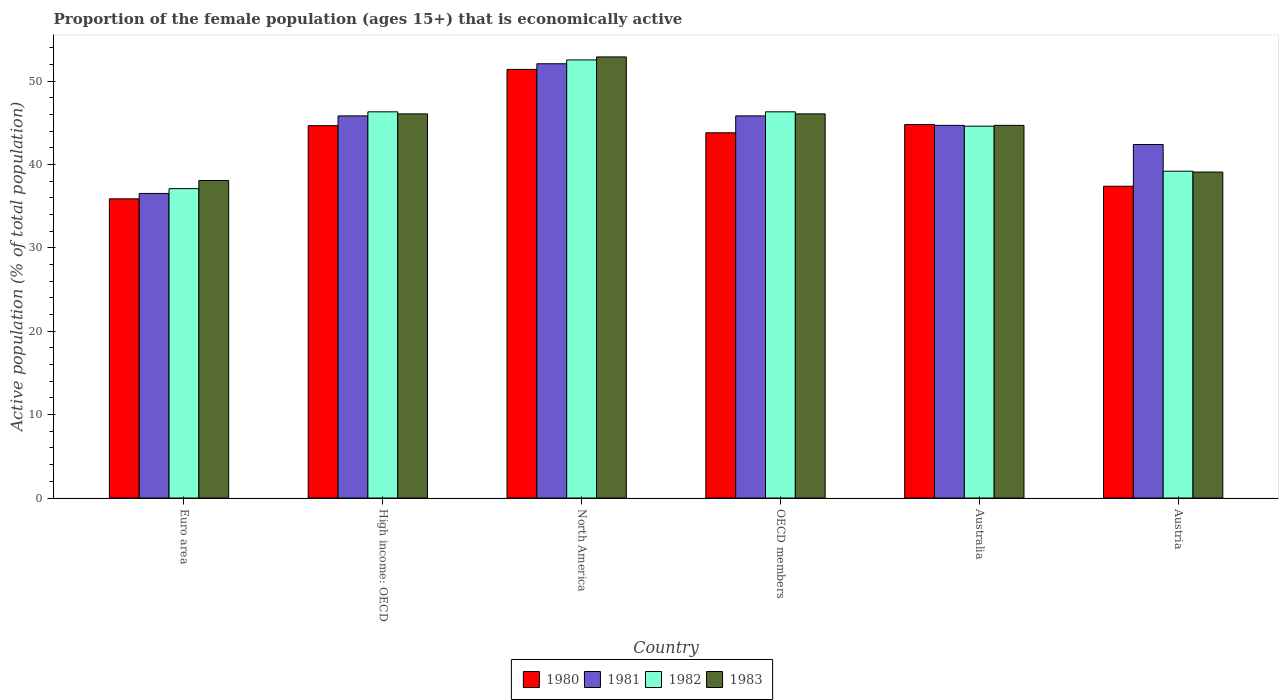How many different coloured bars are there?
Make the answer very short. 4. How many bars are there on the 6th tick from the left?
Provide a succinct answer. 4. What is the label of the 1st group of bars from the left?
Provide a short and direct response. Euro area. In how many cases, is the number of bars for a given country not equal to the number of legend labels?
Provide a succinct answer. 0. What is the proportion of the female population that is economically active in 1981 in High income: OECD?
Provide a succinct answer. 45.84. Across all countries, what is the maximum proportion of the female population that is economically active in 1983?
Your answer should be compact. 52.91. Across all countries, what is the minimum proportion of the female population that is economically active in 1982?
Ensure brevity in your answer.  37.11. In which country was the proportion of the female population that is economically active in 1982 maximum?
Your answer should be compact. North America. In which country was the proportion of the female population that is economically active in 1982 minimum?
Provide a succinct answer. Euro area. What is the total proportion of the female population that is economically active in 1982 in the graph?
Make the answer very short. 266.11. What is the difference between the proportion of the female population that is economically active in 1982 in Australia and that in High income: OECD?
Ensure brevity in your answer.  -1.72. What is the difference between the proportion of the female population that is economically active in 1983 in Euro area and the proportion of the female population that is economically active in 1981 in Austria?
Provide a short and direct response. -4.31. What is the average proportion of the female population that is economically active in 1981 per country?
Make the answer very short. 44.57. What is the difference between the proportion of the female population that is economically active of/in 1981 and proportion of the female population that is economically active of/in 1983 in OECD members?
Offer a very short reply. -0.24. What is the ratio of the proportion of the female population that is economically active in 1982 in Australia to that in Austria?
Give a very brief answer. 1.14. Is the difference between the proportion of the female population that is economically active in 1981 in Australia and Euro area greater than the difference between the proportion of the female population that is economically active in 1983 in Australia and Euro area?
Your answer should be compact. Yes. What is the difference between the highest and the second highest proportion of the female population that is economically active in 1983?
Offer a very short reply. 6.83. What is the difference between the highest and the lowest proportion of the female population that is economically active in 1981?
Your answer should be compact. 15.56. What does the 3rd bar from the right in OECD members represents?
Offer a very short reply. 1981. Are all the bars in the graph horizontal?
Your response must be concise. No. What is the difference between two consecutive major ticks on the Y-axis?
Your response must be concise. 10. Are the values on the major ticks of Y-axis written in scientific E-notation?
Provide a succinct answer. No. Does the graph contain any zero values?
Offer a very short reply. No. Does the graph contain grids?
Offer a terse response. No. How are the legend labels stacked?
Make the answer very short. Horizontal. What is the title of the graph?
Make the answer very short. Proportion of the female population (ages 15+) that is economically active. What is the label or title of the X-axis?
Offer a terse response. Country. What is the label or title of the Y-axis?
Provide a short and direct response. Active population (% of total population). What is the Active population (% of total population) in 1980 in Euro area?
Ensure brevity in your answer.  35.89. What is the Active population (% of total population) of 1981 in Euro area?
Provide a short and direct response. 36.53. What is the Active population (% of total population) in 1982 in Euro area?
Provide a short and direct response. 37.11. What is the Active population (% of total population) of 1983 in Euro area?
Give a very brief answer. 38.09. What is the Active population (% of total population) of 1980 in High income: OECD?
Make the answer very short. 44.66. What is the Active population (% of total population) in 1981 in High income: OECD?
Your answer should be very brief. 45.84. What is the Active population (% of total population) in 1982 in High income: OECD?
Keep it short and to the point. 46.32. What is the Active population (% of total population) of 1983 in High income: OECD?
Your answer should be very brief. 46.08. What is the Active population (% of total population) of 1980 in North America?
Ensure brevity in your answer.  51.41. What is the Active population (% of total population) in 1981 in North America?
Give a very brief answer. 52.09. What is the Active population (% of total population) in 1982 in North America?
Offer a very short reply. 52.55. What is the Active population (% of total population) in 1983 in North America?
Provide a short and direct response. 52.91. What is the Active population (% of total population) of 1980 in OECD members?
Your response must be concise. 43.81. What is the Active population (% of total population) of 1981 in OECD members?
Your answer should be very brief. 45.84. What is the Active population (% of total population) in 1982 in OECD members?
Ensure brevity in your answer.  46.32. What is the Active population (% of total population) of 1983 in OECD members?
Your answer should be compact. 46.08. What is the Active population (% of total population) of 1980 in Australia?
Provide a short and direct response. 44.8. What is the Active population (% of total population) of 1981 in Australia?
Ensure brevity in your answer.  44.7. What is the Active population (% of total population) of 1982 in Australia?
Offer a very short reply. 44.6. What is the Active population (% of total population) in 1983 in Australia?
Ensure brevity in your answer.  44.7. What is the Active population (% of total population) in 1980 in Austria?
Your answer should be very brief. 37.4. What is the Active population (% of total population) of 1981 in Austria?
Offer a very short reply. 42.4. What is the Active population (% of total population) of 1982 in Austria?
Keep it short and to the point. 39.2. What is the Active population (% of total population) in 1983 in Austria?
Ensure brevity in your answer.  39.1. Across all countries, what is the maximum Active population (% of total population) in 1980?
Your answer should be compact. 51.41. Across all countries, what is the maximum Active population (% of total population) of 1981?
Your answer should be very brief. 52.09. Across all countries, what is the maximum Active population (% of total population) in 1982?
Your response must be concise. 52.55. Across all countries, what is the maximum Active population (% of total population) of 1983?
Provide a succinct answer. 52.91. Across all countries, what is the minimum Active population (% of total population) of 1980?
Provide a succinct answer. 35.89. Across all countries, what is the minimum Active population (% of total population) in 1981?
Give a very brief answer. 36.53. Across all countries, what is the minimum Active population (% of total population) in 1982?
Keep it short and to the point. 37.11. Across all countries, what is the minimum Active population (% of total population) in 1983?
Keep it short and to the point. 38.09. What is the total Active population (% of total population) in 1980 in the graph?
Provide a succinct answer. 257.97. What is the total Active population (% of total population) of 1981 in the graph?
Your answer should be compact. 267.4. What is the total Active population (% of total population) of 1982 in the graph?
Provide a succinct answer. 266.11. What is the total Active population (% of total population) in 1983 in the graph?
Your answer should be compact. 266.95. What is the difference between the Active population (% of total population) of 1980 in Euro area and that in High income: OECD?
Keep it short and to the point. -8.78. What is the difference between the Active population (% of total population) of 1981 in Euro area and that in High income: OECD?
Your response must be concise. -9.3. What is the difference between the Active population (% of total population) in 1982 in Euro area and that in High income: OECD?
Your answer should be very brief. -9.22. What is the difference between the Active population (% of total population) of 1983 in Euro area and that in High income: OECD?
Your answer should be very brief. -7.99. What is the difference between the Active population (% of total population) in 1980 in Euro area and that in North America?
Ensure brevity in your answer.  -15.53. What is the difference between the Active population (% of total population) of 1981 in Euro area and that in North America?
Your answer should be compact. -15.56. What is the difference between the Active population (% of total population) in 1982 in Euro area and that in North America?
Your response must be concise. -15.44. What is the difference between the Active population (% of total population) of 1983 in Euro area and that in North America?
Provide a succinct answer. -14.82. What is the difference between the Active population (% of total population) in 1980 in Euro area and that in OECD members?
Provide a succinct answer. -7.92. What is the difference between the Active population (% of total population) in 1981 in Euro area and that in OECD members?
Offer a terse response. -9.3. What is the difference between the Active population (% of total population) of 1982 in Euro area and that in OECD members?
Give a very brief answer. -9.22. What is the difference between the Active population (% of total population) in 1983 in Euro area and that in OECD members?
Give a very brief answer. -7.99. What is the difference between the Active population (% of total population) of 1980 in Euro area and that in Australia?
Offer a terse response. -8.91. What is the difference between the Active population (% of total population) of 1981 in Euro area and that in Australia?
Offer a very short reply. -8.17. What is the difference between the Active population (% of total population) of 1982 in Euro area and that in Australia?
Ensure brevity in your answer.  -7.49. What is the difference between the Active population (% of total population) of 1983 in Euro area and that in Australia?
Give a very brief answer. -6.61. What is the difference between the Active population (% of total population) in 1980 in Euro area and that in Austria?
Provide a succinct answer. -1.51. What is the difference between the Active population (% of total population) of 1981 in Euro area and that in Austria?
Your response must be concise. -5.87. What is the difference between the Active population (% of total population) in 1982 in Euro area and that in Austria?
Provide a succinct answer. -2.09. What is the difference between the Active population (% of total population) of 1983 in Euro area and that in Austria?
Ensure brevity in your answer.  -1.01. What is the difference between the Active population (% of total population) in 1980 in High income: OECD and that in North America?
Ensure brevity in your answer.  -6.75. What is the difference between the Active population (% of total population) in 1981 in High income: OECD and that in North America?
Your response must be concise. -6.25. What is the difference between the Active population (% of total population) of 1982 in High income: OECD and that in North America?
Offer a very short reply. -6.23. What is the difference between the Active population (% of total population) of 1983 in High income: OECD and that in North America?
Your answer should be very brief. -6.83. What is the difference between the Active population (% of total population) in 1980 in High income: OECD and that in OECD members?
Offer a terse response. 0.85. What is the difference between the Active population (% of total population) of 1981 in High income: OECD and that in OECD members?
Offer a terse response. 0. What is the difference between the Active population (% of total population) in 1980 in High income: OECD and that in Australia?
Provide a short and direct response. -0.14. What is the difference between the Active population (% of total population) of 1981 in High income: OECD and that in Australia?
Ensure brevity in your answer.  1.14. What is the difference between the Active population (% of total population) of 1982 in High income: OECD and that in Australia?
Offer a very short reply. 1.72. What is the difference between the Active population (% of total population) in 1983 in High income: OECD and that in Australia?
Your response must be concise. 1.38. What is the difference between the Active population (% of total population) in 1980 in High income: OECD and that in Austria?
Keep it short and to the point. 7.26. What is the difference between the Active population (% of total population) of 1981 in High income: OECD and that in Austria?
Your answer should be compact. 3.44. What is the difference between the Active population (% of total population) of 1982 in High income: OECD and that in Austria?
Your answer should be compact. 7.12. What is the difference between the Active population (% of total population) of 1983 in High income: OECD and that in Austria?
Ensure brevity in your answer.  6.98. What is the difference between the Active population (% of total population) of 1980 in North America and that in OECD members?
Provide a succinct answer. 7.61. What is the difference between the Active population (% of total population) of 1981 in North America and that in OECD members?
Ensure brevity in your answer.  6.25. What is the difference between the Active population (% of total population) of 1982 in North America and that in OECD members?
Your answer should be very brief. 6.23. What is the difference between the Active population (% of total population) in 1983 in North America and that in OECD members?
Your response must be concise. 6.83. What is the difference between the Active population (% of total population) of 1980 in North America and that in Australia?
Your answer should be very brief. 6.61. What is the difference between the Active population (% of total population) in 1981 in North America and that in Australia?
Give a very brief answer. 7.39. What is the difference between the Active population (% of total population) of 1982 in North America and that in Australia?
Give a very brief answer. 7.95. What is the difference between the Active population (% of total population) of 1983 in North America and that in Australia?
Your answer should be compact. 8.21. What is the difference between the Active population (% of total population) in 1980 in North America and that in Austria?
Make the answer very short. 14.01. What is the difference between the Active population (% of total population) in 1981 in North America and that in Austria?
Your answer should be compact. 9.69. What is the difference between the Active population (% of total population) of 1982 in North America and that in Austria?
Your response must be concise. 13.35. What is the difference between the Active population (% of total population) in 1983 in North America and that in Austria?
Your answer should be very brief. 13.81. What is the difference between the Active population (% of total population) of 1980 in OECD members and that in Australia?
Offer a very short reply. -0.99. What is the difference between the Active population (% of total population) in 1981 in OECD members and that in Australia?
Your answer should be compact. 1.14. What is the difference between the Active population (% of total population) of 1982 in OECD members and that in Australia?
Your answer should be compact. 1.72. What is the difference between the Active population (% of total population) of 1983 in OECD members and that in Australia?
Your answer should be very brief. 1.38. What is the difference between the Active population (% of total population) of 1980 in OECD members and that in Austria?
Your answer should be very brief. 6.41. What is the difference between the Active population (% of total population) of 1981 in OECD members and that in Austria?
Offer a very short reply. 3.44. What is the difference between the Active population (% of total population) of 1982 in OECD members and that in Austria?
Provide a succinct answer. 7.12. What is the difference between the Active population (% of total population) of 1983 in OECD members and that in Austria?
Provide a short and direct response. 6.98. What is the difference between the Active population (% of total population) of 1980 in Australia and that in Austria?
Keep it short and to the point. 7.4. What is the difference between the Active population (% of total population) of 1981 in Australia and that in Austria?
Make the answer very short. 2.3. What is the difference between the Active population (% of total population) of 1980 in Euro area and the Active population (% of total population) of 1981 in High income: OECD?
Offer a terse response. -9.95. What is the difference between the Active population (% of total population) of 1980 in Euro area and the Active population (% of total population) of 1982 in High income: OECD?
Provide a succinct answer. -10.44. What is the difference between the Active population (% of total population) of 1980 in Euro area and the Active population (% of total population) of 1983 in High income: OECD?
Your answer should be very brief. -10.19. What is the difference between the Active population (% of total population) of 1981 in Euro area and the Active population (% of total population) of 1982 in High income: OECD?
Your response must be concise. -9.79. What is the difference between the Active population (% of total population) in 1981 in Euro area and the Active population (% of total population) in 1983 in High income: OECD?
Ensure brevity in your answer.  -9.54. What is the difference between the Active population (% of total population) in 1982 in Euro area and the Active population (% of total population) in 1983 in High income: OECD?
Offer a terse response. -8.97. What is the difference between the Active population (% of total population) in 1980 in Euro area and the Active population (% of total population) in 1981 in North America?
Your answer should be compact. -16.2. What is the difference between the Active population (% of total population) of 1980 in Euro area and the Active population (% of total population) of 1982 in North America?
Give a very brief answer. -16.67. What is the difference between the Active population (% of total population) in 1980 in Euro area and the Active population (% of total population) in 1983 in North America?
Offer a very short reply. -17.02. What is the difference between the Active population (% of total population) in 1981 in Euro area and the Active population (% of total population) in 1982 in North America?
Provide a succinct answer. -16.02. What is the difference between the Active population (% of total population) in 1981 in Euro area and the Active population (% of total population) in 1983 in North America?
Ensure brevity in your answer.  -16.38. What is the difference between the Active population (% of total population) of 1982 in Euro area and the Active population (% of total population) of 1983 in North America?
Provide a succinct answer. -15.8. What is the difference between the Active population (% of total population) of 1980 in Euro area and the Active population (% of total population) of 1981 in OECD members?
Provide a succinct answer. -9.95. What is the difference between the Active population (% of total population) in 1980 in Euro area and the Active population (% of total population) in 1982 in OECD members?
Your answer should be very brief. -10.44. What is the difference between the Active population (% of total population) in 1980 in Euro area and the Active population (% of total population) in 1983 in OECD members?
Make the answer very short. -10.19. What is the difference between the Active population (% of total population) in 1981 in Euro area and the Active population (% of total population) in 1982 in OECD members?
Give a very brief answer. -9.79. What is the difference between the Active population (% of total population) of 1981 in Euro area and the Active population (% of total population) of 1983 in OECD members?
Offer a terse response. -9.54. What is the difference between the Active population (% of total population) of 1982 in Euro area and the Active population (% of total population) of 1983 in OECD members?
Offer a terse response. -8.97. What is the difference between the Active population (% of total population) in 1980 in Euro area and the Active population (% of total population) in 1981 in Australia?
Offer a terse response. -8.81. What is the difference between the Active population (% of total population) of 1980 in Euro area and the Active population (% of total population) of 1982 in Australia?
Your response must be concise. -8.71. What is the difference between the Active population (% of total population) of 1980 in Euro area and the Active population (% of total population) of 1983 in Australia?
Offer a terse response. -8.81. What is the difference between the Active population (% of total population) in 1981 in Euro area and the Active population (% of total population) in 1982 in Australia?
Offer a very short reply. -8.07. What is the difference between the Active population (% of total population) of 1981 in Euro area and the Active population (% of total population) of 1983 in Australia?
Provide a succinct answer. -8.17. What is the difference between the Active population (% of total population) in 1982 in Euro area and the Active population (% of total population) in 1983 in Australia?
Offer a very short reply. -7.59. What is the difference between the Active population (% of total population) of 1980 in Euro area and the Active population (% of total population) of 1981 in Austria?
Keep it short and to the point. -6.51. What is the difference between the Active population (% of total population) in 1980 in Euro area and the Active population (% of total population) in 1982 in Austria?
Provide a short and direct response. -3.31. What is the difference between the Active population (% of total population) in 1980 in Euro area and the Active population (% of total population) in 1983 in Austria?
Give a very brief answer. -3.21. What is the difference between the Active population (% of total population) of 1981 in Euro area and the Active population (% of total population) of 1982 in Austria?
Make the answer very short. -2.67. What is the difference between the Active population (% of total population) in 1981 in Euro area and the Active population (% of total population) in 1983 in Austria?
Give a very brief answer. -2.57. What is the difference between the Active population (% of total population) in 1982 in Euro area and the Active population (% of total population) in 1983 in Austria?
Provide a short and direct response. -1.99. What is the difference between the Active population (% of total population) of 1980 in High income: OECD and the Active population (% of total population) of 1981 in North America?
Provide a short and direct response. -7.43. What is the difference between the Active population (% of total population) in 1980 in High income: OECD and the Active population (% of total population) in 1982 in North America?
Give a very brief answer. -7.89. What is the difference between the Active population (% of total population) in 1980 in High income: OECD and the Active population (% of total population) in 1983 in North America?
Offer a terse response. -8.25. What is the difference between the Active population (% of total population) of 1981 in High income: OECD and the Active population (% of total population) of 1982 in North America?
Keep it short and to the point. -6.72. What is the difference between the Active population (% of total population) of 1981 in High income: OECD and the Active population (% of total population) of 1983 in North America?
Provide a succinct answer. -7.07. What is the difference between the Active population (% of total population) of 1982 in High income: OECD and the Active population (% of total population) of 1983 in North America?
Make the answer very short. -6.58. What is the difference between the Active population (% of total population) in 1980 in High income: OECD and the Active population (% of total population) in 1981 in OECD members?
Make the answer very short. -1.17. What is the difference between the Active population (% of total population) in 1980 in High income: OECD and the Active population (% of total population) in 1982 in OECD members?
Offer a terse response. -1.66. What is the difference between the Active population (% of total population) in 1980 in High income: OECD and the Active population (% of total population) in 1983 in OECD members?
Offer a very short reply. -1.42. What is the difference between the Active population (% of total population) in 1981 in High income: OECD and the Active population (% of total population) in 1982 in OECD members?
Make the answer very short. -0.49. What is the difference between the Active population (% of total population) in 1981 in High income: OECD and the Active population (% of total population) in 1983 in OECD members?
Ensure brevity in your answer.  -0.24. What is the difference between the Active population (% of total population) in 1982 in High income: OECD and the Active population (% of total population) in 1983 in OECD members?
Offer a terse response. 0.25. What is the difference between the Active population (% of total population) of 1980 in High income: OECD and the Active population (% of total population) of 1981 in Australia?
Your answer should be compact. -0.04. What is the difference between the Active population (% of total population) of 1980 in High income: OECD and the Active population (% of total population) of 1982 in Australia?
Ensure brevity in your answer.  0.06. What is the difference between the Active population (% of total population) of 1980 in High income: OECD and the Active population (% of total population) of 1983 in Australia?
Make the answer very short. -0.04. What is the difference between the Active population (% of total population) in 1981 in High income: OECD and the Active population (% of total population) in 1982 in Australia?
Offer a very short reply. 1.24. What is the difference between the Active population (% of total population) of 1981 in High income: OECD and the Active population (% of total population) of 1983 in Australia?
Offer a very short reply. 1.14. What is the difference between the Active population (% of total population) of 1982 in High income: OECD and the Active population (% of total population) of 1983 in Australia?
Offer a terse response. 1.62. What is the difference between the Active population (% of total population) in 1980 in High income: OECD and the Active population (% of total population) in 1981 in Austria?
Provide a short and direct response. 2.26. What is the difference between the Active population (% of total population) in 1980 in High income: OECD and the Active population (% of total population) in 1982 in Austria?
Keep it short and to the point. 5.46. What is the difference between the Active population (% of total population) of 1980 in High income: OECD and the Active population (% of total population) of 1983 in Austria?
Your response must be concise. 5.56. What is the difference between the Active population (% of total population) in 1981 in High income: OECD and the Active population (% of total population) in 1982 in Austria?
Your response must be concise. 6.64. What is the difference between the Active population (% of total population) in 1981 in High income: OECD and the Active population (% of total population) in 1983 in Austria?
Provide a succinct answer. 6.74. What is the difference between the Active population (% of total population) in 1982 in High income: OECD and the Active population (% of total population) in 1983 in Austria?
Your answer should be compact. 7.22. What is the difference between the Active population (% of total population) in 1980 in North America and the Active population (% of total population) in 1981 in OECD members?
Give a very brief answer. 5.58. What is the difference between the Active population (% of total population) of 1980 in North America and the Active population (% of total population) of 1982 in OECD members?
Keep it short and to the point. 5.09. What is the difference between the Active population (% of total population) of 1980 in North America and the Active population (% of total population) of 1983 in OECD members?
Keep it short and to the point. 5.34. What is the difference between the Active population (% of total population) in 1981 in North America and the Active population (% of total population) in 1982 in OECD members?
Your answer should be very brief. 5.77. What is the difference between the Active population (% of total population) of 1981 in North America and the Active population (% of total population) of 1983 in OECD members?
Offer a very short reply. 6.01. What is the difference between the Active population (% of total population) of 1982 in North America and the Active population (% of total population) of 1983 in OECD members?
Provide a short and direct response. 6.47. What is the difference between the Active population (% of total population) in 1980 in North America and the Active population (% of total population) in 1981 in Australia?
Your response must be concise. 6.71. What is the difference between the Active population (% of total population) of 1980 in North America and the Active population (% of total population) of 1982 in Australia?
Keep it short and to the point. 6.81. What is the difference between the Active population (% of total population) of 1980 in North America and the Active population (% of total population) of 1983 in Australia?
Provide a succinct answer. 6.71. What is the difference between the Active population (% of total population) of 1981 in North America and the Active population (% of total population) of 1982 in Australia?
Give a very brief answer. 7.49. What is the difference between the Active population (% of total population) in 1981 in North America and the Active population (% of total population) in 1983 in Australia?
Your response must be concise. 7.39. What is the difference between the Active population (% of total population) of 1982 in North America and the Active population (% of total population) of 1983 in Australia?
Your response must be concise. 7.85. What is the difference between the Active population (% of total population) in 1980 in North America and the Active population (% of total population) in 1981 in Austria?
Ensure brevity in your answer.  9.01. What is the difference between the Active population (% of total population) in 1980 in North America and the Active population (% of total population) in 1982 in Austria?
Give a very brief answer. 12.21. What is the difference between the Active population (% of total population) in 1980 in North America and the Active population (% of total population) in 1983 in Austria?
Give a very brief answer. 12.31. What is the difference between the Active population (% of total population) of 1981 in North America and the Active population (% of total population) of 1982 in Austria?
Your response must be concise. 12.89. What is the difference between the Active population (% of total population) in 1981 in North America and the Active population (% of total population) in 1983 in Austria?
Your response must be concise. 12.99. What is the difference between the Active population (% of total population) of 1982 in North America and the Active population (% of total population) of 1983 in Austria?
Offer a terse response. 13.45. What is the difference between the Active population (% of total population) in 1980 in OECD members and the Active population (% of total population) in 1981 in Australia?
Give a very brief answer. -0.89. What is the difference between the Active population (% of total population) of 1980 in OECD members and the Active population (% of total population) of 1982 in Australia?
Provide a short and direct response. -0.79. What is the difference between the Active population (% of total population) of 1980 in OECD members and the Active population (% of total population) of 1983 in Australia?
Keep it short and to the point. -0.89. What is the difference between the Active population (% of total population) of 1981 in OECD members and the Active population (% of total population) of 1982 in Australia?
Offer a terse response. 1.24. What is the difference between the Active population (% of total population) in 1981 in OECD members and the Active population (% of total population) in 1983 in Australia?
Provide a succinct answer. 1.14. What is the difference between the Active population (% of total population) in 1982 in OECD members and the Active population (% of total population) in 1983 in Australia?
Provide a short and direct response. 1.62. What is the difference between the Active population (% of total population) of 1980 in OECD members and the Active population (% of total population) of 1981 in Austria?
Offer a very short reply. 1.41. What is the difference between the Active population (% of total population) of 1980 in OECD members and the Active population (% of total population) of 1982 in Austria?
Your answer should be very brief. 4.61. What is the difference between the Active population (% of total population) in 1980 in OECD members and the Active population (% of total population) in 1983 in Austria?
Offer a terse response. 4.71. What is the difference between the Active population (% of total population) of 1981 in OECD members and the Active population (% of total population) of 1982 in Austria?
Your response must be concise. 6.64. What is the difference between the Active population (% of total population) in 1981 in OECD members and the Active population (% of total population) in 1983 in Austria?
Provide a short and direct response. 6.74. What is the difference between the Active population (% of total population) in 1982 in OECD members and the Active population (% of total population) in 1983 in Austria?
Provide a short and direct response. 7.22. What is the difference between the Active population (% of total population) of 1981 in Australia and the Active population (% of total population) of 1982 in Austria?
Make the answer very short. 5.5. What is the difference between the Active population (% of total population) of 1981 in Australia and the Active population (% of total population) of 1983 in Austria?
Ensure brevity in your answer.  5.6. What is the average Active population (% of total population) of 1980 per country?
Offer a very short reply. 43. What is the average Active population (% of total population) in 1981 per country?
Your answer should be compact. 44.57. What is the average Active population (% of total population) of 1982 per country?
Provide a succinct answer. 44.35. What is the average Active population (% of total population) in 1983 per country?
Make the answer very short. 44.49. What is the difference between the Active population (% of total population) in 1980 and Active population (% of total population) in 1981 in Euro area?
Your answer should be very brief. -0.65. What is the difference between the Active population (% of total population) in 1980 and Active population (% of total population) in 1982 in Euro area?
Keep it short and to the point. -1.22. What is the difference between the Active population (% of total population) in 1980 and Active population (% of total population) in 1983 in Euro area?
Make the answer very short. -2.2. What is the difference between the Active population (% of total population) in 1981 and Active population (% of total population) in 1982 in Euro area?
Offer a very short reply. -0.57. What is the difference between the Active population (% of total population) of 1981 and Active population (% of total population) of 1983 in Euro area?
Your answer should be very brief. -1.55. What is the difference between the Active population (% of total population) of 1982 and Active population (% of total population) of 1983 in Euro area?
Give a very brief answer. -0.98. What is the difference between the Active population (% of total population) in 1980 and Active population (% of total population) in 1981 in High income: OECD?
Offer a very short reply. -1.17. What is the difference between the Active population (% of total population) in 1980 and Active population (% of total population) in 1982 in High income: OECD?
Your answer should be compact. -1.66. What is the difference between the Active population (% of total population) in 1980 and Active population (% of total population) in 1983 in High income: OECD?
Offer a terse response. -1.42. What is the difference between the Active population (% of total population) of 1981 and Active population (% of total population) of 1982 in High income: OECD?
Give a very brief answer. -0.49. What is the difference between the Active population (% of total population) in 1981 and Active population (% of total population) in 1983 in High income: OECD?
Make the answer very short. -0.24. What is the difference between the Active population (% of total population) of 1982 and Active population (% of total population) of 1983 in High income: OECD?
Provide a short and direct response. 0.25. What is the difference between the Active population (% of total population) in 1980 and Active population (% of total population) in 1981 in North America?
Ensure brevity in your answer.  -0.68. What is the difference between the Active population (% of total population) in 1980 and Active population (% of total population) in 1982 in North America?
Your answer should be compact. -1.14. What is the difference between the Active population (% of total population) of 1980 and Active population (% of total population) of 1983 in North America?
Your response must be concise. -1.5. What is the difference between the Active population (% of total population) of 1981 and Active population (% of total population) of 1982 in North America?
Your answer should be very brief. -0.46. What is the difference between the Active population (% of total population) in 1981 and Active population (% of total population) in 1983 in North America?
Offer a terse response. -0.82. What is the difference between the Active population (% of total population) in 1982 and Active population (% of total population) in 1983 in North America?
Provide a short and direct response. -0.36. What is the difference between the Active population (% of total population) in 1980 and Active population (% of total population) in 1981 in OECD members?
Ensure brevity in your answer.  -2.03. What is the difference between the Active population (% of total population) of 1980 and Active population (% of total population) of 1982 in OECD members?
Offer a very short reply. -2.52. What is the difference between the Active population (% of total population) in 1980 and Active population (% of total population) in 1983 in OECD members?
Provide a short and direct response. -2.27. What is the difference between the Active population (% of total population) in 1981 and Active population (% of total population) in 1982 in OECD members?
Give a very brief answer. -0.49. What is the difference between the Active population (% of total population) of 1981 and Active population (% of total population) of 1983 in OECD members?
Give a very brief answer. -0.24. What is the difference between the Active population (% of total population) in 1982 and Active population (% of total population) in 1983 in OECD members?
Provide a succinct answer. 0.25. What is the difference between the Active population (% of total population) of 1980 and Active population (% of total population) of 1983 in Australia?
Your answer should be very brief. 0.1. What is the difference between the Active population (% of total population) in 1981 and Active population (% of total population) in 1983 in Australia?
Your response must be concise. 0. What is the difference between the Active population (% of total population) of 1982 and Active population (% of total population) of 1983 in Australia?
Make the answer very short. -0.1. What is the difference between the Active population (% of total population) in 1980 and Active population (% of total population) in 1983 in Austria?
Give a very brief answer. -1.7. What is the difference between the Active population (% of total population) in 1982 and Active population (% of total population) in 1983 in Austria?
Your answer should be compact. 0.1. What is the ratio of the Active population (% of total population) in 1980 in Euro area to that in High income: OECD?
Make the answer very short. 0.8. What is the ratio of the Active population (% of total population) of 1981 in Euro area to that in High income: OECD?
Provide a succinct answer. 0.8. What is the ratio of the Active population (% of total population) in 1982 in Euro area to that in High income: OECD?
Ensure brevity in your answer.  0.8. What is the ratio of the Active population (% of total population) in 1983 in Euro area to that in High income: OECD?
Give a very brief answer. 0.83. What is the ratio of the Active population (% of total population) of 1980 in Euro area to that in North America?
Keep it short and to the point. 0.7. What is the ratio of the Active population (% of total population) of 1981 in Euro area to that in North America?
Your answer should be compact. 0.7. What is the ratio of the Active population (% of total population) in 1982 in Euro area to that in North America?
Your response must be concise. 0.71. What is the ratio of the Active population (% of total population) of 1983 in Euro area to that in North America?
Your answer should be very brief. 0.72. What is the ratio of the Active population (% of total population) of 1980 in Euro area to that in OECD members?
Give a very brief answer. 0.82. What is the ratio of the Active population (% of total population) in 1981 in Euro area to that in OECD members?
Your answer should be very brief. 0.8. What is the ratio of the Active population (% of total population) of 1982 in Euro area to that in OECD members?
Keep it short and to the point. 0.8. What is the ratio of the Active population (% of total population) of 1983 in Euro area to that in OECD members?
Offer a terse response. 0.83. What is the ratio of the Active population (% of total population) in 1980 in Euro area to that in Australia?
Offer a terse response. 0.8. What is the ratio of the Active population (% of total population) of 1981 in Euro area to that in Australia?
Give a very brief answer. 0.82. What is the ratio of the Active population (% of total population) of 1982 in Euro area to that in Australia?
Provide a short and direct response. 0.83. What is the ratio of the Active population (% of total population) in 1983 in Euro area to that in Australia?
Your response must be concise. 0.85. What is the ratio of the Active population (% of total population) of 1980 in Euro area to that in Austria?
Your answer should be very brief. 0.96. What is the ratio of the Active population (% of total population) in 1981 in Euro area to that in Austria?
Provide a succinct answer. 0.86. What is the ratio of the Active population (% of total population) in 1982 in Euro area to that in Austria?
Your response must be concise. 0.95. What is the ratio of the Active population (% of total population) of 1983 in Euro area to that in Austria?
Ensure brevity in your answer.  0.97. What is the ratio of the Active population (% of total population) in 1980 in High income: OECD to that in North America?
Your answer should be compact. 0.87. What is the ratio of the Active population (% of total population) of 1981 in High income: OECD to that in North America?
Make the answer very short. 0.88. What is the ratio of the Active population (% of total population) of 1982 in High income: OECD to that in North America?
Provide a short and direct response. 0.88. What is the ratio of the Active population (% of total population) of 1983 in High income: OECD to that in North America?
Your answer should be compact. 0.87. What is the ratio of the Active population (% of total population) of 1980 in High income: OECD to that in OECD members?
Ensure brevity in your answer.  1.02. What is the ratio of the Active population (% of total population) of 1981 in High income: OECD to that in Australia?
Ensure brevity in your answer.  1.03. What is the ratio of the Active population (% of total population) in 1982 in High income: OECD to that in Australia?
Your answer should be very brief. 1.04. What is the ratio of the Active population (% of total population) in 1983 in High income: OECD to that in Australia?
Your answer should be compact. 1.03. What is the ratio of the Active population (% of total population) in 1980 in High income: OECD to that in Austria?
Your answer should be compact. 1.19. What is the ratio of the Active population (% of total population) of 1981 in High income: OECD to that in Austria?
Provide a succinct answer. 1.08. What is the ratio of the Active population (% of total population) of 1982 in High income: OECD to that in Austria?
Make the answer very short. 1.18. What is the ratio of the Active population (% of total population) of 1983 in High income: OECD to that in Austria?
Offer a terse response. 1.18. What is the ratio of the Active population (% of total population) of 1980 in North America to that in OECD members?
Offer a terse response. 1.17. What is the ratio of the Active population (% of total population) of 1981 in North America to that in OECD members?
Your answer should be compact. 1.14. What is the ratio of the Active population (% of total population) in 1982 in North America to that in OECD members?
Offer a terse response. 1.13. What is the ratio of the Active population (% of total population) in 1983 in North America to that in OECD members?
Keep it short and to the point. 1.15. What is the ratio of the Active population (% of total population) in 1980 in North America to that in Australia?
Your answer should be very brief. 1.15. What is the ratio of the Active population (% of total population) of 1981 in North America to that in Australia?
Give a very brief answer. 1.17. What is the ratio of the Active population (% of total population) of 1982 in North America to that in Australia?
Provide a short and direct response. 1.18. What is the ratio of the Active population (% of total population) of 1983 in North America to that in Australia?
Your response must be concise. 1.18. What is the ratio of the Active population (% of total population) in 1980 in North America to that in Austria?
Provide a succinct answer. 1.37. What is the ratio of the Active population (% of total population) of 1981 in North America to that in Austria?
Your answer should be very brief. 1.23. What is the ratio of the Active population (% of total population) of 1982 in North America to that in Austria?
Give a very brief answer. 1.34. What is the ratio of the Active population (% of total population) of 1983 in North America to that in Austria?
Offer a very short reply. 1.35. What is the ratio of the Active population (% of total population) in 1980 in OECD members to that in Australia?
Provide a short and direct response. 0.98. What is the ratio of the Active population (% of total population) in 1981 in OECD members to that in Australia?
Your response must be concise. 1.03. What is the ratio of the Active population (% of total population) in 1982 in OECD members to that in Australia?
Ensure brevity in your answer.  1.04. What is the ratio of the Active population (% of total population) in 1983 in OECD members to that in Australia?
Give a very brief answer. 1.03. What is the ratio of the Active population (% of total population) of 1980 in OECD members to that in Austria?
Your answer should be very brief. 1.17. What is the ratio of the Active population (% of total population) in 1981 in OECD members to that in Austria?
Your answer should be compact. 1.08. What is the ratio of the Active population (% of total population) in 1982 in OECD members to that in Austria?
Ensure brevity in your answer.  1.18. What is the ratio of the Active population (% of total population) of 1983 in OECD members to that in Austria?
Provide a short and direct response. 1.18. What is the ratio of the Active population (% of total population) of 1980 in Australia to that in Austria?
Offer a terse response. 1.2. What is the ratio of the Active population (% of total population) of 1981 in Australia to that in Austria?
Your answer should be compact. 1.05. What is the ratio of the Active population (% of total population) of 1982 in Australia to that in Austria?
Make the answer very short. 1.14. What is the ratio of the Active population (% of total population) of 1983 in Australia to that in Austria?
Make the answer very short. 1.14. What is the difference between the highest and the second highest Active population (% of total population) of 1980?
Provide a short and direct response. 6.61. What is the difference between the highest and the second highest Active population (% of total population) in 1981?
Provide a short and direct response. 6.25. What is the difference between the highest and the second highest Active population (% of total population) of 1982?
Keep it short and to the point. 6.23. What is the difference between the highest and the second highest Active population (% of total population) of 1983?
Make the answer very short. 6.83. What is the difference between the highest and the lowest Active population (% of total population) in 1980?
Your answer should be very brief. 15.53. What is the difference between the highest and the lowest Active population (% of total population) of 1981?
Ensure brevity in your answer.  15.56. What is the difference between the highest and the lowest Active population (% of total population) of 1982?
Offer a very short reply. 15.44. What is the difference between the highest and the lowest Active population (% of total population) of 1983?
Give a very brief answer. 14.82. 